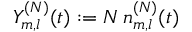Convert formula to latex. <formula><loc_0><loc_0><loc_500><loc_500>Y _ { m , l } ^ { ( N ) } ( t ) \colon = N \, n _ { m , l } ^ { ( N ) } ( t )</formula> 